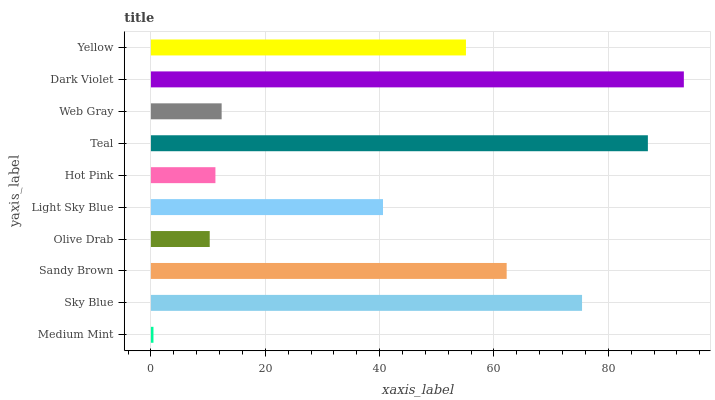Is Medium Mint the minimum?
Answer yes or no. Yes. Is Dark Violet the maximum?
Answer yes or no. Yes. Is Sky Blue the minimum?
Answer yes or no. No. Is Sky Blue the maximum?
Answer yes or no. No. Is Sky Blue greater than Medium Mint?
Answer yes or no. Yes. Is Medium Mint less than Sky Blue?
Answer yes or no. Yes. Is Medium Mint greater than Sky Blue?
Answer yes or no. No. Is Sky Blue less than Medium Mint?
Answer yes or no. No. Is Yellow the high median?
Answer yes or no. Yes. Is Light Sky Blue the low median?
Answer yes or no. Yes. Is Sandy Brown the high median?
Answer yes or no. No. Is Web Gray the low median?
Answer yes or no. No. 